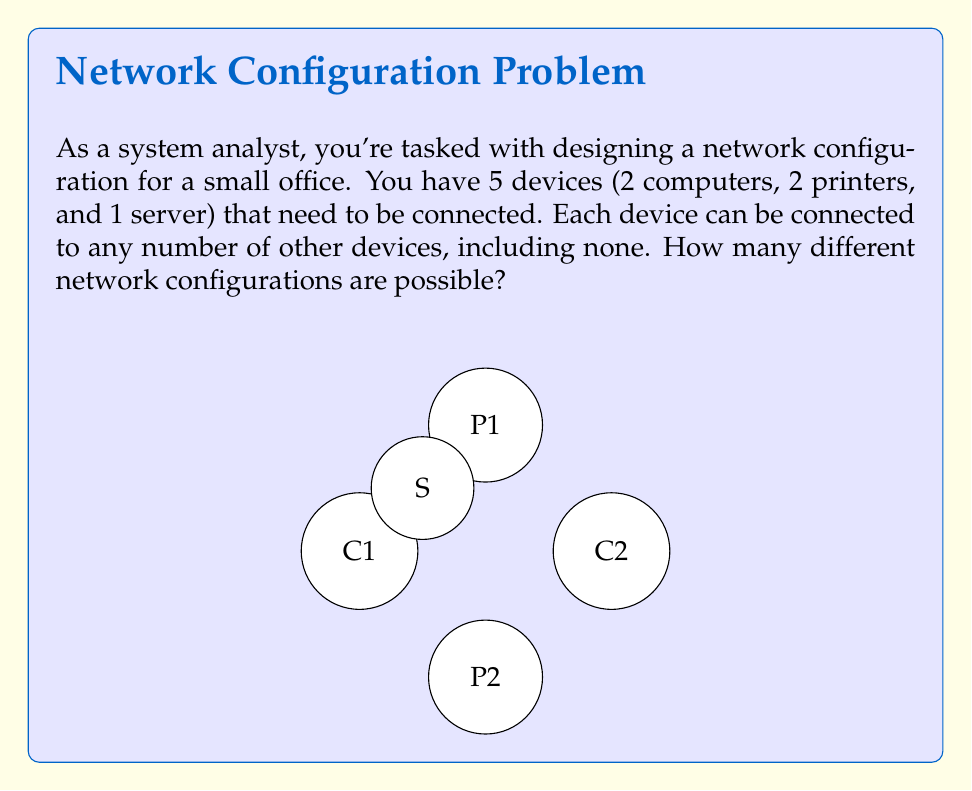Can you solve this math problem? Let's approach this step-by-step:

1) First, we need to understand what determines a unique configuration. In this case, it's the presence or absence of a connection between each pair of devices.

2) With 5 devices, we have $\binom{5}{2} = 10$ possible connections (each pair of devices).

3) For each of these 10 possible connections, we have two choices: the connection is either present or absent.

4) This scenario is equivalent to making 10 independent binary choices, where each choice represents whether a particular connection exists or not.

5) The number of ways to make n independent binary choices is $2^n$.

6) In this case, n = 10, so the total number of possible configurations is $2^{10}$.

7) We can calculate this:

   $$2^{10} = 2 \times 2 \times 2 \times 2 \times 2 \times 2 \times 2 \times 2 \times 2 \times 2 = 1024$$

Therefore, there are 1024 possible network configurations for these 5 devices.
Answer: $2^{10} = 1024$ configurations 